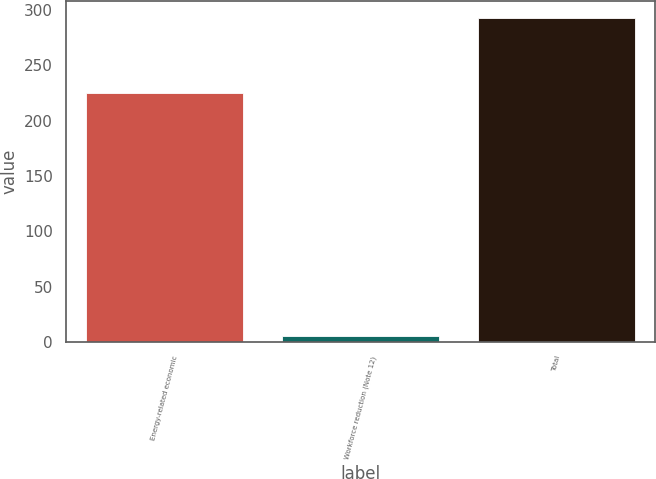Convert chart to OTSL. <chart><loc_0><loc_0><loc_500><loc_500><bar_chart><fcel>Energy-related economic<fcel>Workforce reduction (Note 12)<fcel>Total<nl><fcel>225<fcel>6<fcel>293<nl></chart> 